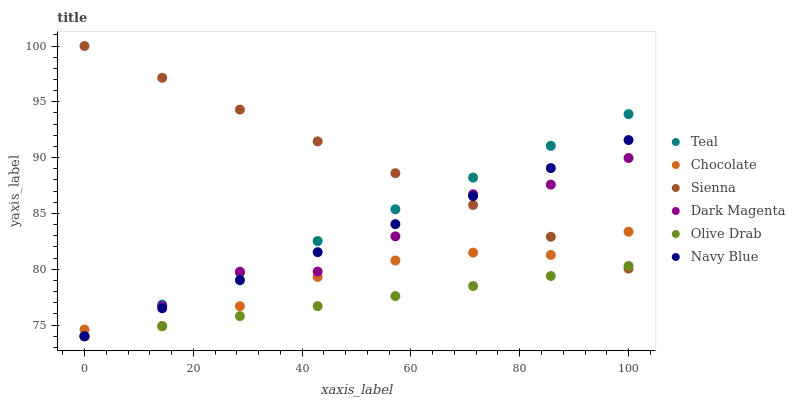Does Olive Drab have the minimum area under the curve?
Answer yes or no. Yes. Does Sienna have the maximum area under the curve?
Answer yes or no. Yes. Does Navy Blue have the minimum area under the curve?
Answer yes or no. No. Does Navy Blue have the maximum area under the curve?
Answer yes or no. No. Is Navy Blue the smoothest?
Answer yes or no. Yes. Is Dark Magenta the roughest?
Answer yes or no. Yes. Is Chocolate the smoothest?
Answer yes or no. No. Is Chocolate the roughest?
Answer yes or no. No. Does Dark Magenta have the lowest value?
Answer yes or no. Yes. Does Chocolate have the lowest value?
Answer yes or no. No. Does Sienna have the highest value?
Answer yes or no. Yes. Does Navy Blue have the highest value?
Answer yes or no. No. Is Olive Drab less than Chocolate?
Answer yes or no. Yes. Is Chocolate greater than Olive Drab?
Answer yes or no. Yes. Does Teal intersect Navy Blue?
Answer yes or no. Yes. Is Teal less than Navy Blue?
Answer yes or no. No. Is Teal greater than Navy Blue?
Answer yes or no. No. Does Olive Drab intersect Chocolate?
Answer yes or no. No. 